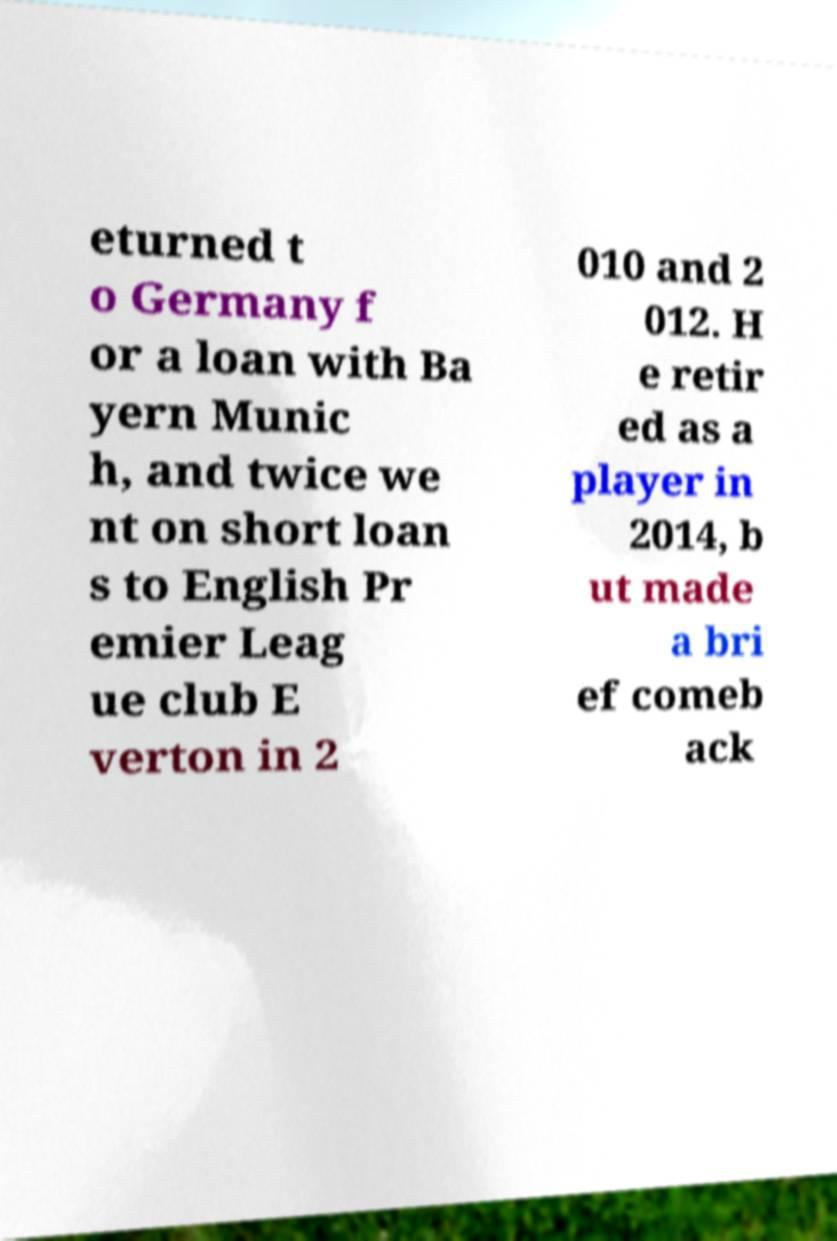Please read and relay the text visible in this image. What does it say? eturned t o Germany f or a loan with Ba yern Munic h, and twice we nt on short loan s to English Pr emier Leag ue club E verton in 2 010 and 2 012. H e retir ed as a player in 2014, b ut made a bri ef comeb ack 